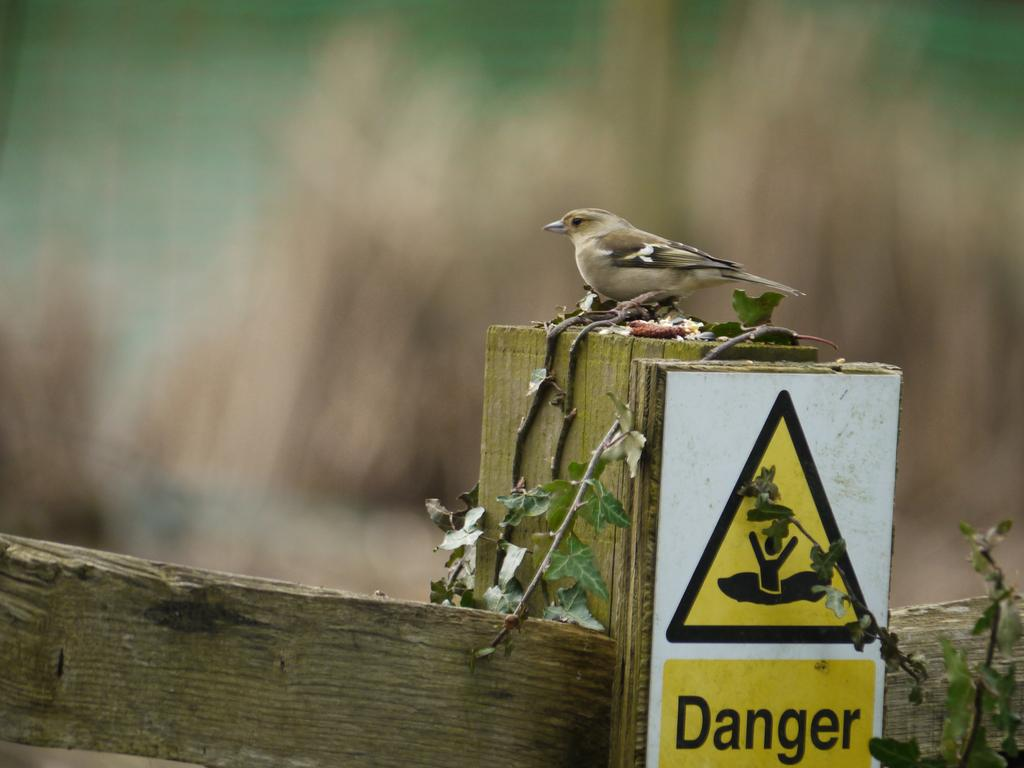What is the main subject of the image? There is a bird on a wooden surface in the image. What else can be seen in the image besides the bird? There is a sign board and plants visible in the image. How would you describe the background of the image? The background of the image is blurred. How many sheets are being held by the bird's wings in the image? There are no sheets present in the image, and the bird's wings are not holding anything. What type of hands can be seen on the bird in the image? Birds do not have hands; they have wings and feet. In the image, the bird has wings and feet, but no hands. 